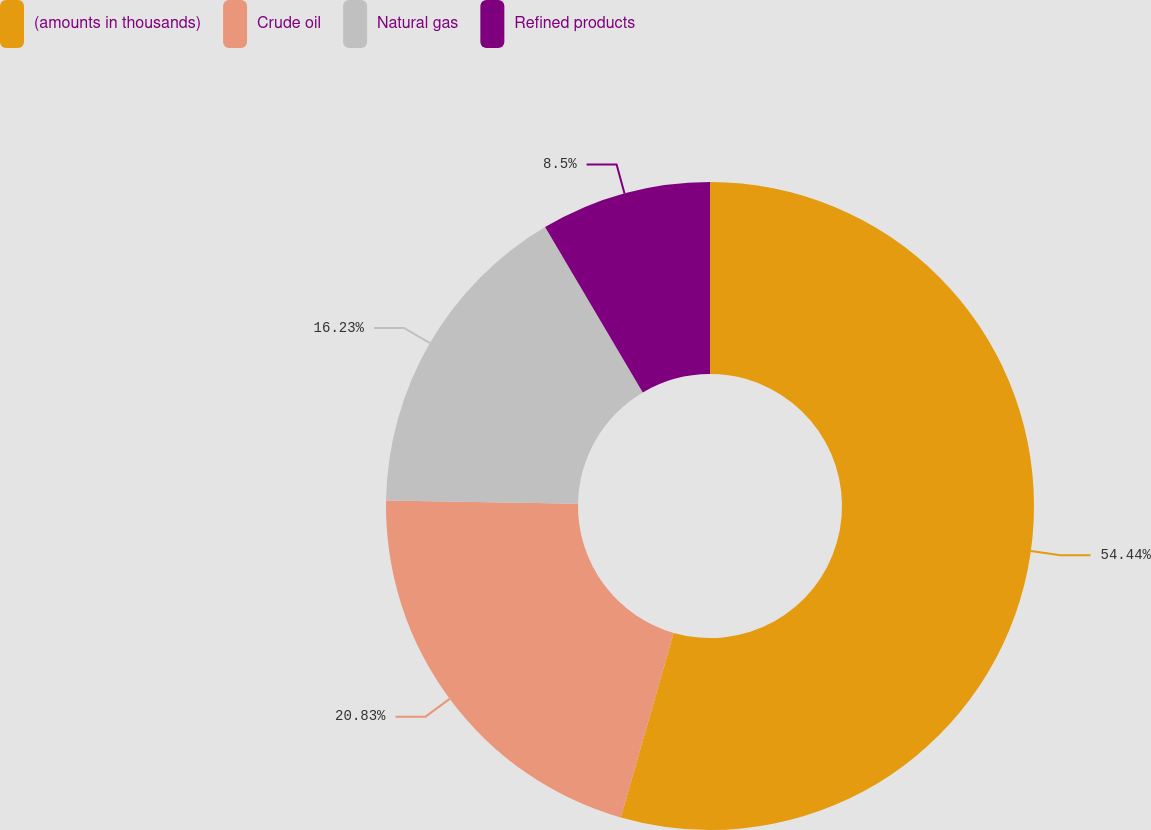Convert chart to OTSL. <chart><loc_0><loc_0><loc_500><loc_500><pie_chart><fcel>(amounts in thousands)<fcel>Crude oil<fcel>Natural gas<fcel>Refined products<nl><fcel>54.44%<fcel>20.83%<fcel>16.23%<fcel>8.5%<nl></chart> 